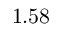<formula> <loc_0><loc_0><loc_500><loc_500>1 . 5 8</formula> 